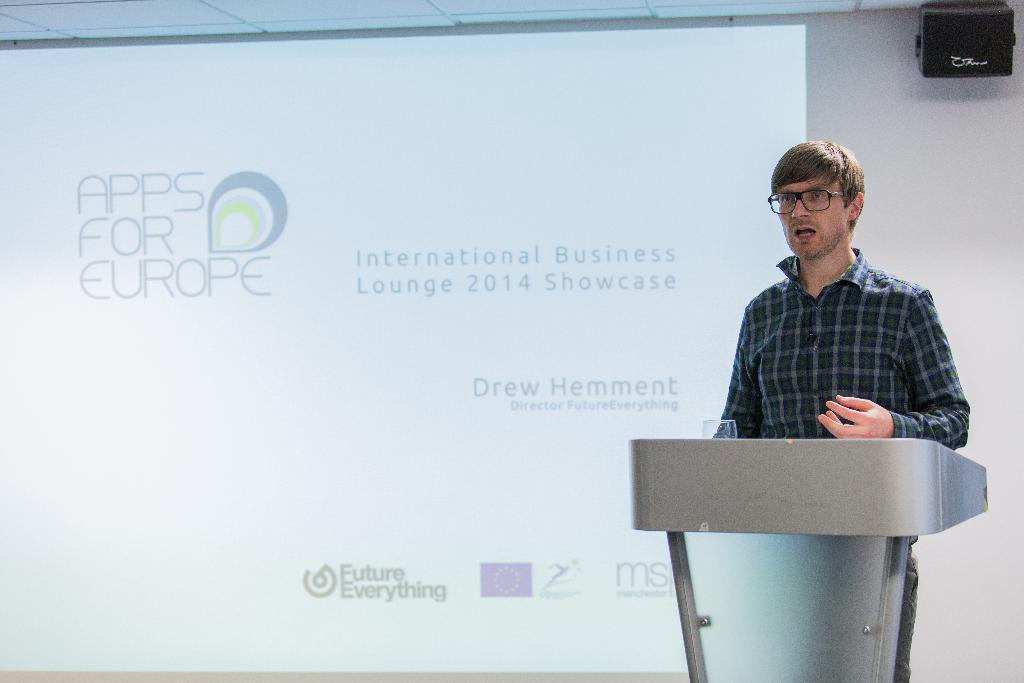Could you give a brief overview of what you see in this image? In this image in the front there is a podium and on the podium there is a glass. In the Center there is a man standing and speaking. In the background there is a wall and on the wall there is a projector running with some text written on it. On the right side there is a speaker which is on the top right. 